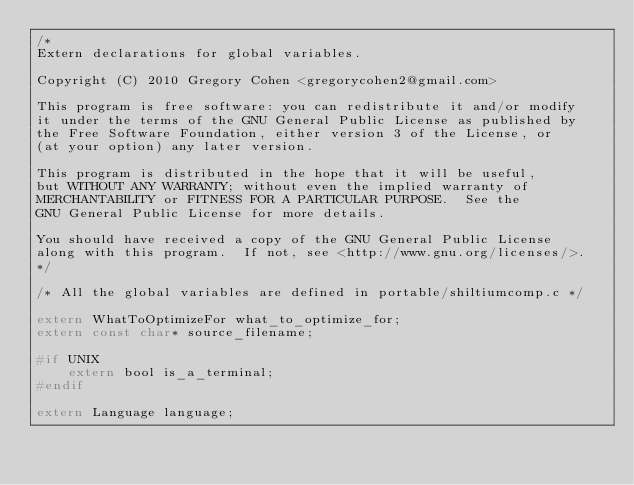Convert code to text. <code><loc_0><loc_0><loc_500><loc_500><_C_>/*
Extern declarations for global variables.

Copyright (C) 2010 Gregory Cohen <gregorycohen2@gmail.com>

This program is free software: you can redistribute it and/or modify
it under the terms of the GNU General Public License as published by
the Free Software Foundation, either version 3 of the License, or
(at your option) any later version.

This program is distributed in the hope that it will be useful,
but WITHOUT ANY WARRANTY; without even the implied warranty of
MERCHANTABILITY or FITNESS FOR A PARTICULAR PURPOSE.  See the
GNU General Public License for more details.

You should have received a copy of the GNU General Public License
along with this program.  If not, see <http://www.gnu.org/licenses/>.
*/

/* All the global variables are defined in portable/shiltiumcomp.c */

extern WhatToOptimizeFor what_to_optimize_for;
extern const char* source_filename;

#if UNIX
	extern bool is_a_terminal;
#endif

extern Language language;
</code> 